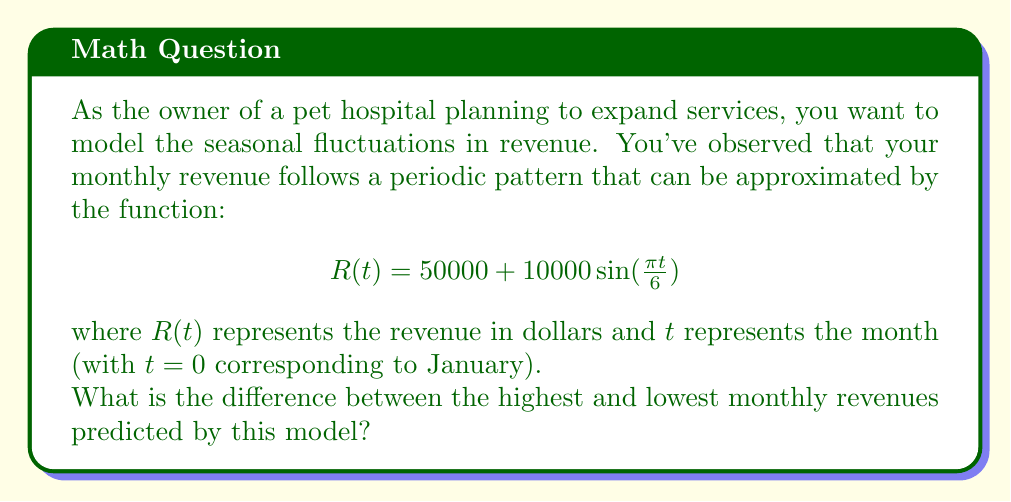Give your solution to this math problem. To solve this problem, we need to find the maximum and minimum values of the given periodic function.

1) The function is in the form: $R(t) = A + B \sin(\omega t)$
   Where $A = 50000$, $B = 10000$, and $\omega = \frac{\pi}{6}$

2) For a sine function, the maximum occurs when $\sin(\omega t) = 1$, and the minimum occurs when $\sin(\omega t) = -1$

3) Therefore:
   Maximum revenue: $R_{max} = 50000 + 10000(1) = 60000$
   Minimum revenue: $R_{min} = 50000 + 10000(-1) = 40000$

4) The difference between the highest and lowest monthly revenues is:
   $R_{max} - R_{min} = 60000 - 40000 = 20000$

This means that the revenue fluctuates by $20,000 between its peak and trough months.
Answer: $20,000 